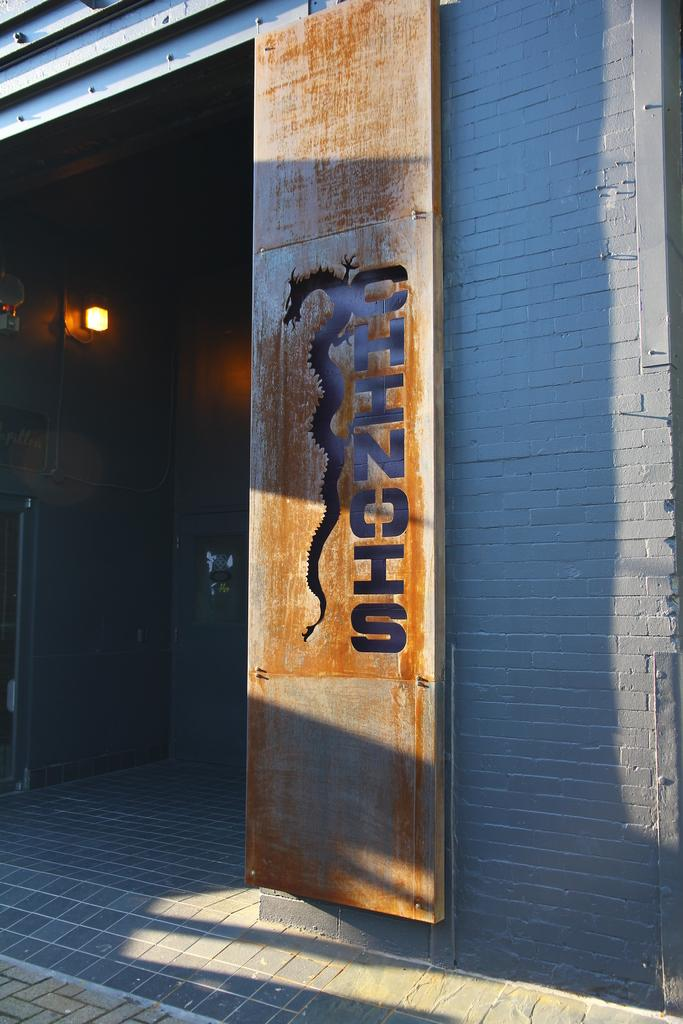What is located in the foreground of the image? There is a door in the foreground of the image. What can be seen on the door? There is text and a dragon-shaped design on the door. What type of structure does the door appear to be a part of? The door appears to be part of a shelter wall. Can you describe the lighting inside the shelter? There is a light visible inside the shelter. What type of reward is being offered to the nation in the image? There is no mention of a reward or nation in the image; it features a door with a dragon-shaped design and text. What level of respect is shown towards the dragon in the image? There is no indication of respect or disrespect towards the dragon in the image; it is simply a design element on the door. 